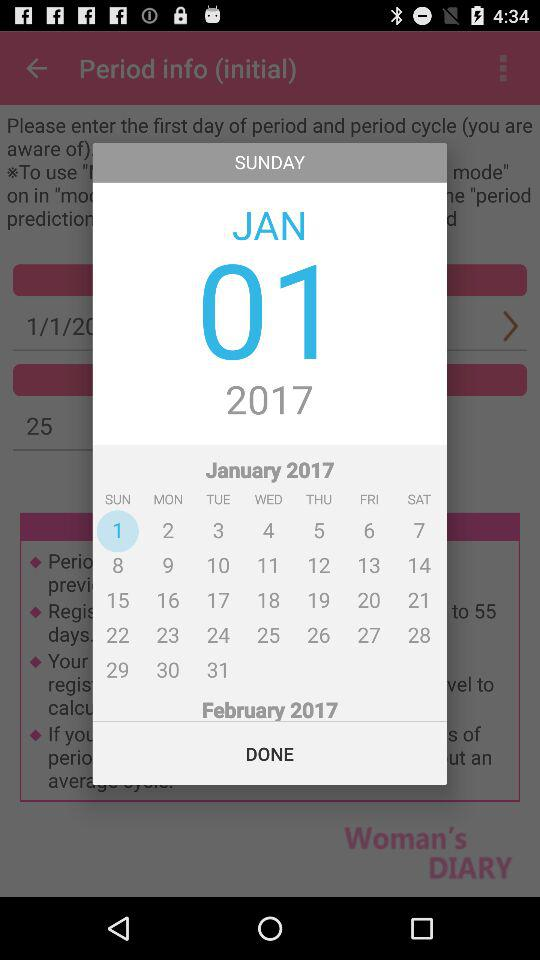Which application version is being used?
When the provided information is insufficient, respond with <no answer>. <no answer> 